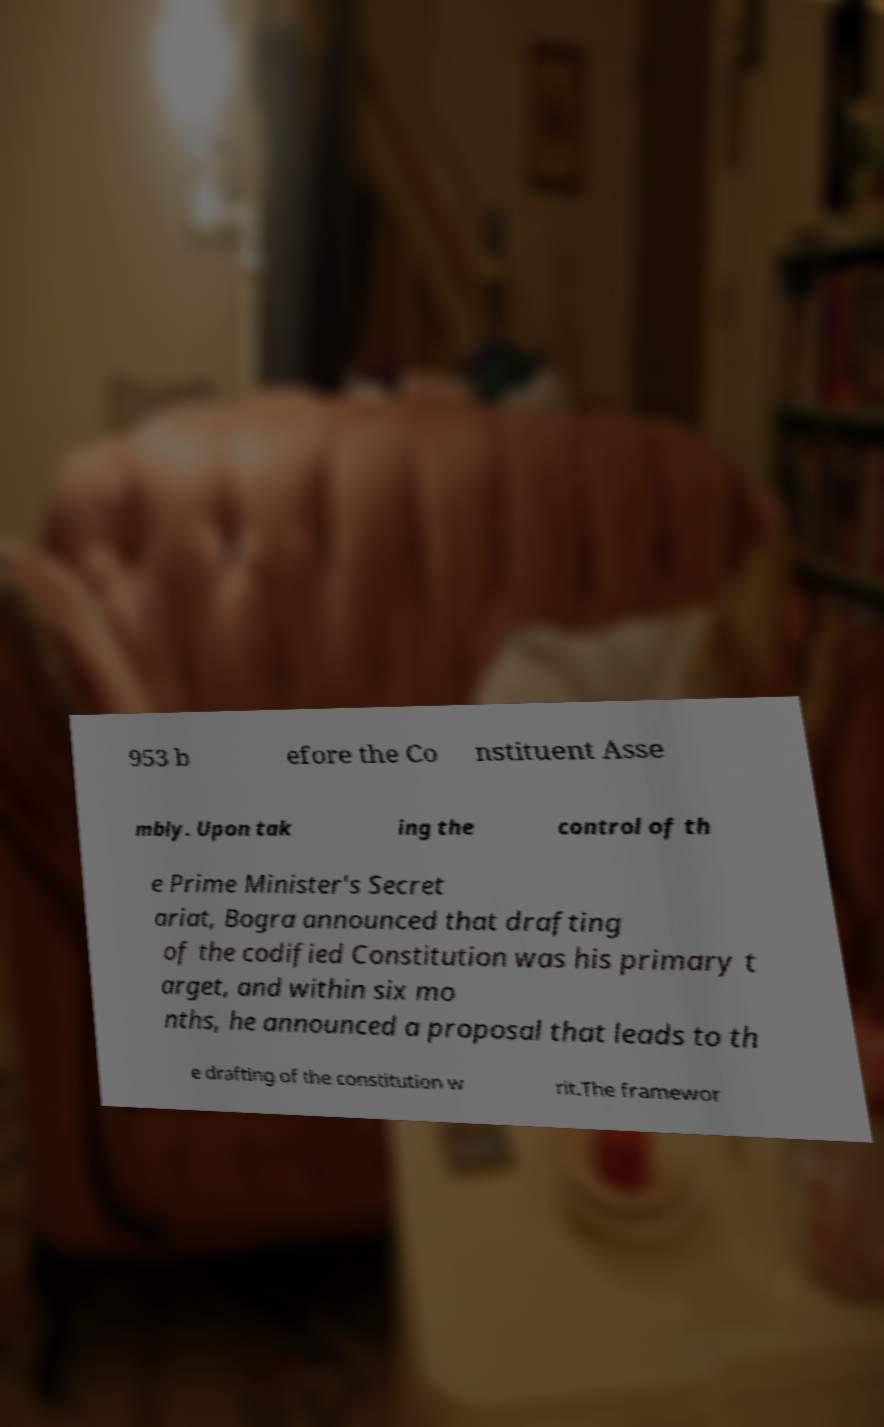There's text embedded in this image that I need extracted. Can you transcribe it verbatim? 953 b efore the Co nstituent Asse mbly. Upon tak ing the control of th e Prime Minister's Secret ariat, Bogra announced that drafting of the codified Constitution was his primary t arget, and within six mo nths, he announced a proposal that leads to th e drafting of the constitution w rit.The framewor 